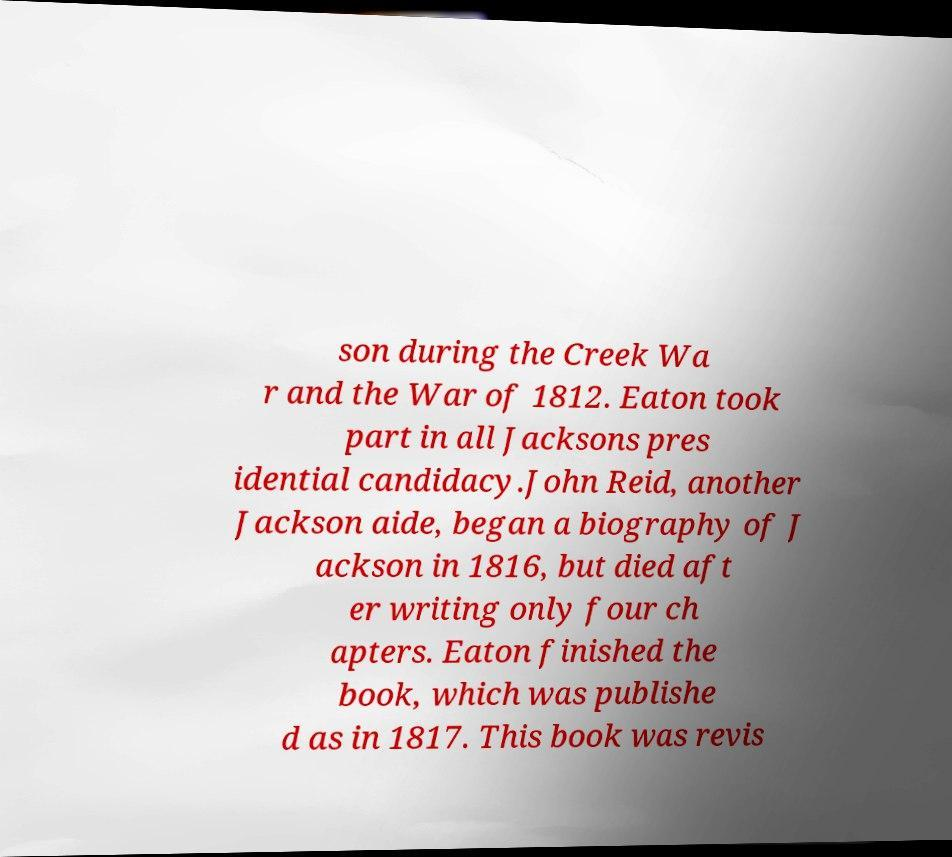Please identify and transcribe the text found in this image. son during the Creek Wa r and the War of 1812. Eaton took part in all Jacksons pres idential candidacy.John Reid, another Jackson aide, began a biography of J ackson in 1816, but died aft er writing only four ch apters. Eaton finished the book, which was publishe d as in 1817. This book was revis 